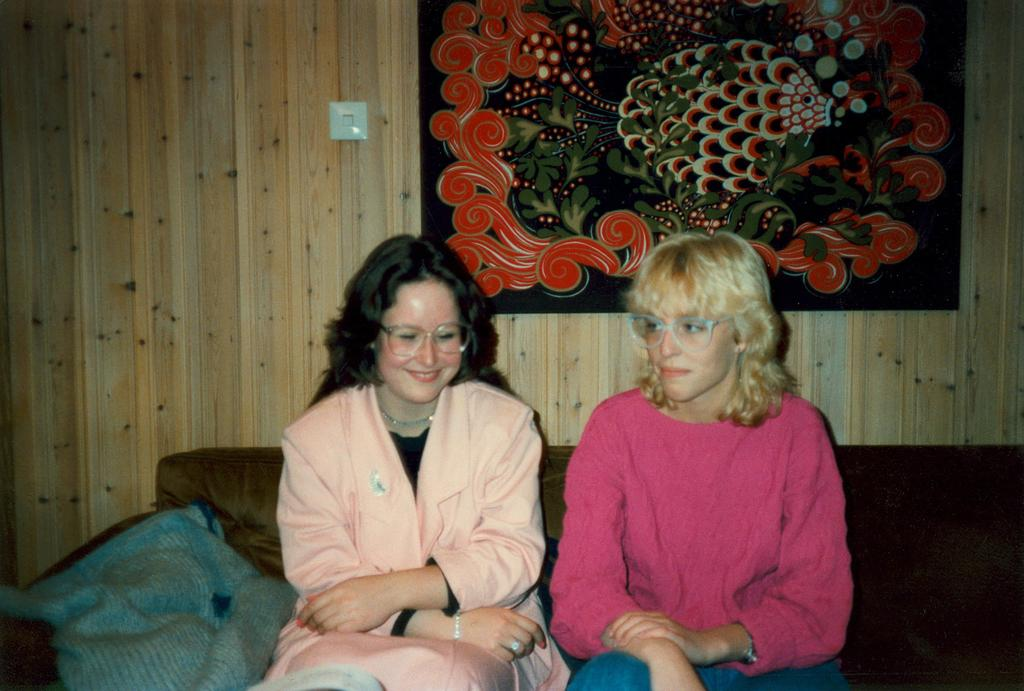How many women are in the image? There are two women in the image. What are the women wearing? Both women are wearing spectacles. Where are the women sitting? The women are sitting on a sofa. What expression do the women have? The women are smiling. What can be seen beside the women? There is a cloth beside the women. What is visible in the background of the image? There is a frame on the wall in the background. What type of plantation can be seen in the image? There is no plantation present in the image. What is the rate of the fan in the image? There is no fan present in the image, so it is not possible to determine its rate. 